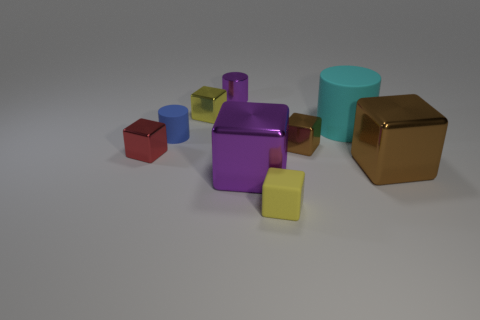There is a brown shiny thing that is behind the tiny red metal block that is on the left side of the tiny matte thing to the left of the rubber block; what shape is it?
Your answer should be compact. Cube. Do the red object and the yellow object in front of the blue rubber cylinder have the same size?
Give a very brief answer. Yes. There is a thing that is both behind the tiny blue matte object and on the right side of the tiny purple cylinder; what is its shape?
Provide a succinct answer. Cylinder. How many big things are either cyan metallic cylinders or red metal things?
Offer a very short reply. 0. Are there an equal number of small shiny blocks that are in front of the big cylinder and tiny brown objects that are in front of the large purple metallic block?
Your answer should be compact. No. How many other things are there of the same color as the metal cylinder?
Offer a very short reply. 1. Is the number of tiny things that are on the right side of the large purple thing the same as the number of red metallic blocks?
Offer a terse response. No. Do the blue matte cylinder and the cyan matte thing have the same size?
Provide a succinct answer. No. What is the cylinder that is left of the large cyan matte cylinder and in front of the yellow metallic cube made of?
Keep it short and to the point. Rubber. How many tiny brown things have the same shape as the tiny blue object?
Make the answer very short. 0. 